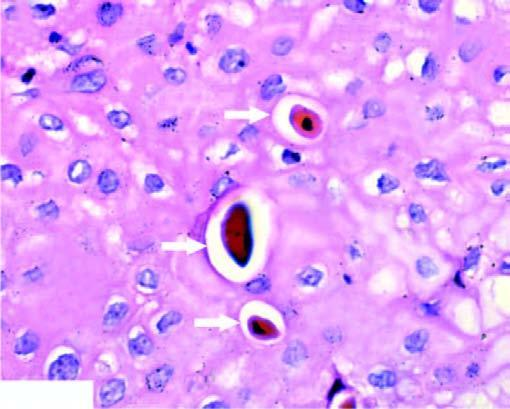what is seen in singles?
Answer the question using a single word or phrase. The dead cell singles 